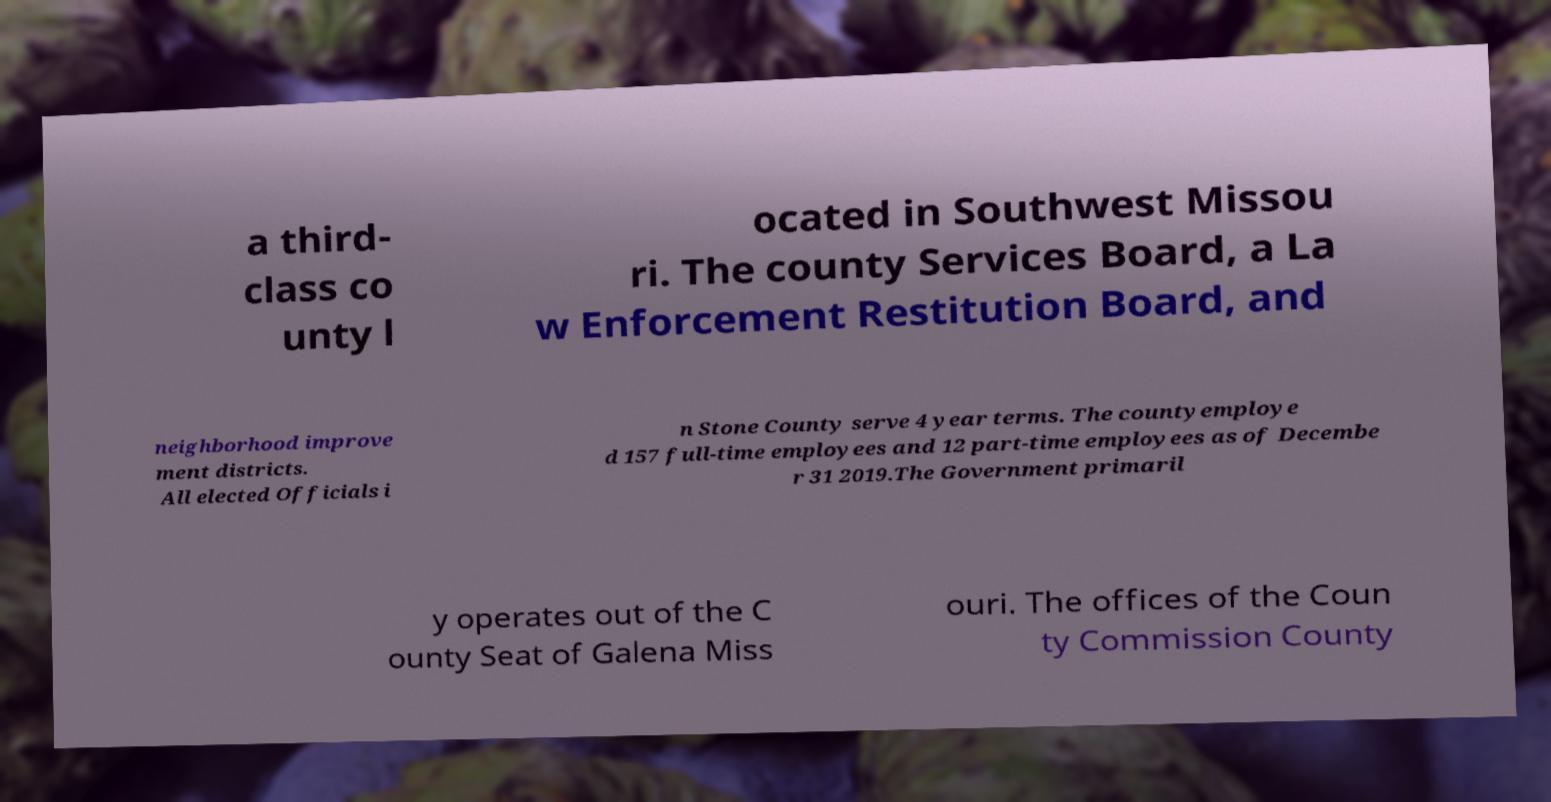I need the written content from this picture converted into text. Can you do that? a third- class co unty l ocated in Southwest Missou ri. The county Services Board, a La w Enforcement Restitution Board, and neighborhood improve ment districts. All elected Officials i n Stone County serve 4 year terms. The countyemploye d 157 full-time employees and 12 part-time employees as of Decembe r 31 2019.The Government primaril y operates out of the C ounty Seat of Galena Miss ouri. The offices of the Coun ty Commission County 